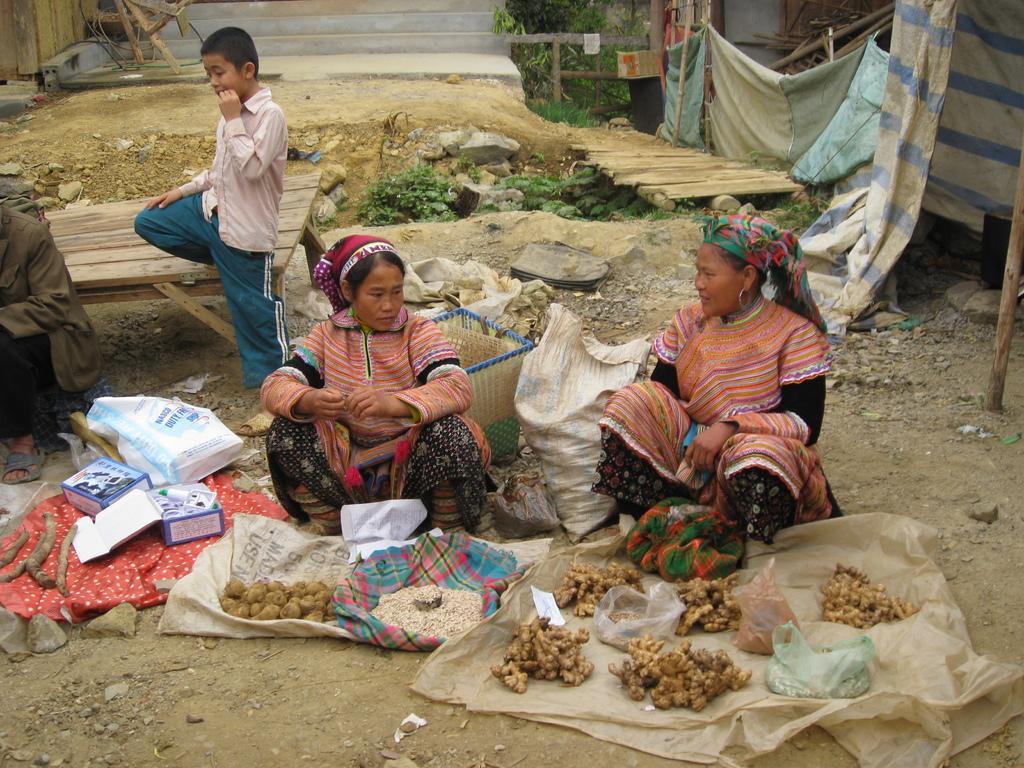How would you summarize this image in a sentence or two? In this picture I can see 2 women who are sitting and in front of them I see number of things and I see the stones on the ground and I see a boy who is standing near to these women and I see a person on the left side. In the background I see the clothes and I see the plants and I see the path. 